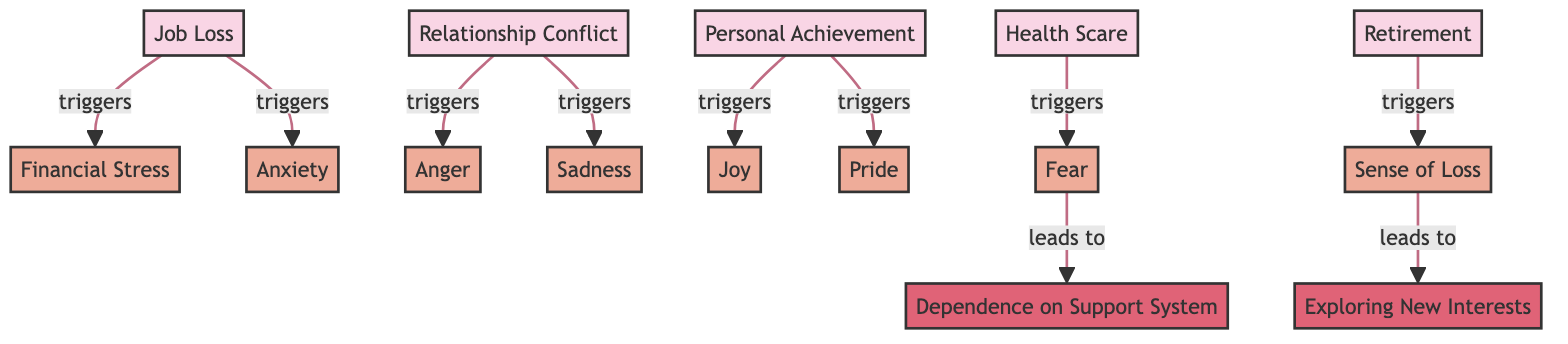What is the total number of emotional responses depicted in the diagram? The diagram lists six nodes classified as emotional responses: Financial Stress, Anxiety, Anger, Sadness, Joy, Pride, Fear, and Sense of Loss. Counting these gives a total of seven emotional responses.
Answer: seven Which event triggers both Anger and Sadness? The diagram shows that Relationship Conflict triggers both Anger and Sadness as indicated by the edges connecting these nodes.
Answer: Relationship Conflict What emotional response follows Fear according to the diagram? The diagram indicates that Fear leads to Dependence on Support System, as depicted by the edge connecting Fear to Dependence on Support System.
Answer: Dependence on Support System How many coping mechanisms are represented in the diagram? The diagram lists two coping mechanisms: Dependence on Support System and Exploring New Interests, thus counting these gives a total of two coping mechanisms.
Answer: two Which event is associated with the emotional response of Joy? According to the diagram, Personal Achievement is linked to the emotional response of Joy, as shown by the connection between these nodes.
Answer: Personal Achievement What is the relationship between Job Loss and Financial Stress? The diagram shows that Job Loss triggers Financial Stress, which is depicted by the edge connecting Job Loss to Financial Stress.
Answer: triggers Which emotional response leads to Exploring New Interests? The diagram specifies that Sense of Loss leads to Exploring New Interests, as indicated by the flow from Sense of Loss to Exploring New Interests.
Answer: Sense of Loss Which two emotional responses are triggered by Personal Achievement? The diagram indicates that Personal Achievement triggers both Joy and Pride, as shown by the edges connecting Personal Achievement to these emotional responses.
Answer: Joy and Pride 